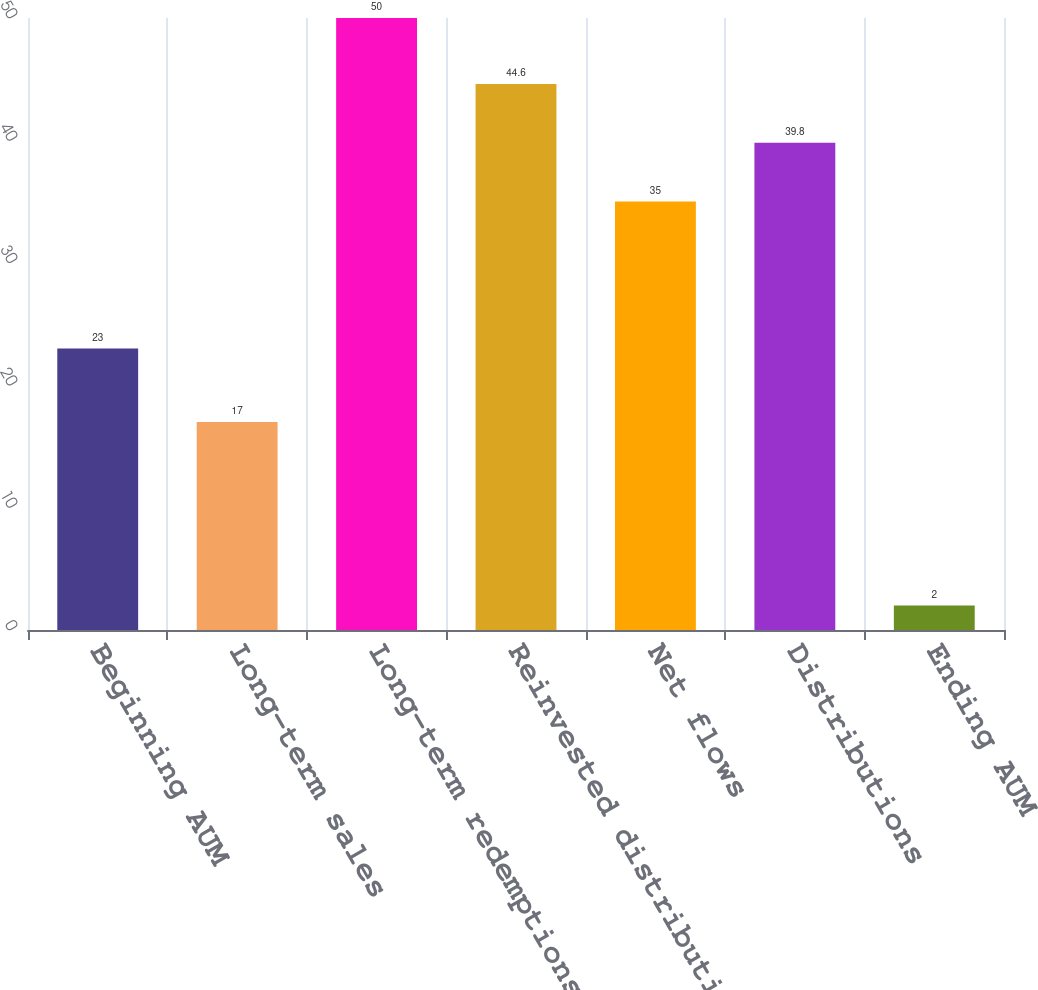Convert chart. <chart><loc_0><loc_0><loc_500><loc_500><bar_chart><fcel>Beginning AUM<fcel>Long-term sales<fcel>Long-term redemptions<fcel>Reinvested distributions<fcel>Net flows<fcel>Distributions<fcel>Ending AUM<nl><fcel>23<fcel>17<fcel>50<fcel>44.6<fcel>35<fcel>39.8<fcel>2<nl></chart> 